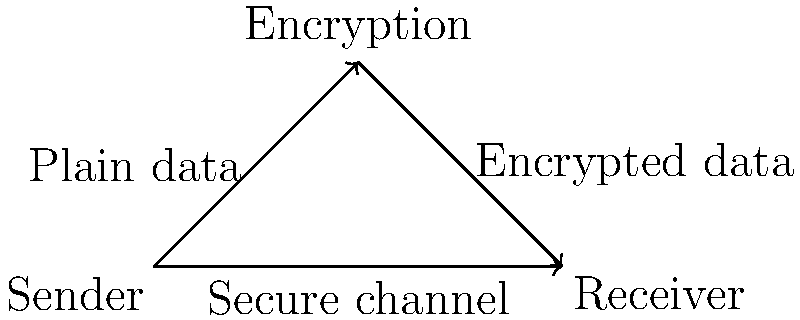In the secure data transmission protocol illustrated above, what critical step ensures the confidentiality of sensitive claims information during transmission from the sender to the receiver? The diagram illustrates a secure data transmission protocol, which is crucial for protecting sensitive claims information. Let's break down the process:

1. The sender (e.g., a healthcare provider) has plain, unencrypted data that needs to be transmitted securely.

2. Before transmission, the data goes through an encryption process. This is represented by the arrow from "Sender" to "Encryption" labeled "Plain data".

3. The encryption process uses complex algorithms to convert the plain data into an unreadable format, creating encrypted data.

4. The encrypted data is then sent to the receiver (e.g., the insurance company or claims processing system) through a secure channel. This is shown by the arrow from "Encryption" to "Receiver" labeled "Encrypted data".

5. The secure channel (represented by the direct arrow from "Sender" to "Receiver") ensures that the encrypted data is transmitted safely without interception.

6. Upon receipt, the receiver decrypts the data (not shown in the diagram) to access the original information.

The critical step that ensures confidentiality during transmission is the encryption process. It transforms the sensitive claims information into a format that cannot be read or understood if intercepted during transmission. This protects the data from unauthorized access and maintains the privacy of patient information, which is essential for compliance with regulations like HIPAA in healthcare claims management.
Answer: Encryption 